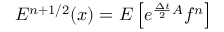<formula> <loc_0><loc_0><loc_500><loc_500>E ^ { n + 1 / 2 } ( x ) = E \left [ e ^ { \frac { \Delta t } { 2 } A } f ^ { n } \right ]</formula> 